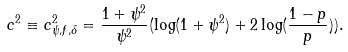<formula> <loc_0><loc_0><loc_500><loc_500>c ^ { 2 } \equiv c ^ { 2 } _ { \psi , f , \delta } = \frac { 1 + \psi ^ { 2 } } { \psi ^ { 2 } } ( \log ( 1 + \psi ^ { 2 } ) + 2 \log ( \frac { 1 - p } { p } ) ) .</formula> 